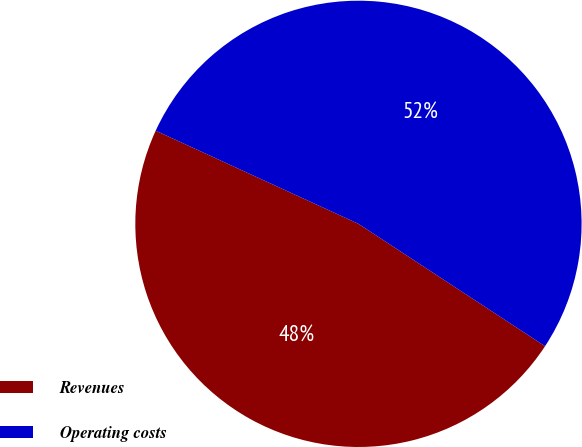<chart> <loc_0><loc_0><loc_500><loc_500><pie_chart><fcel>Revenues<fcel>Operating costs<nl><fcel>47.62%<fcel>52.38%<nl></chart> 